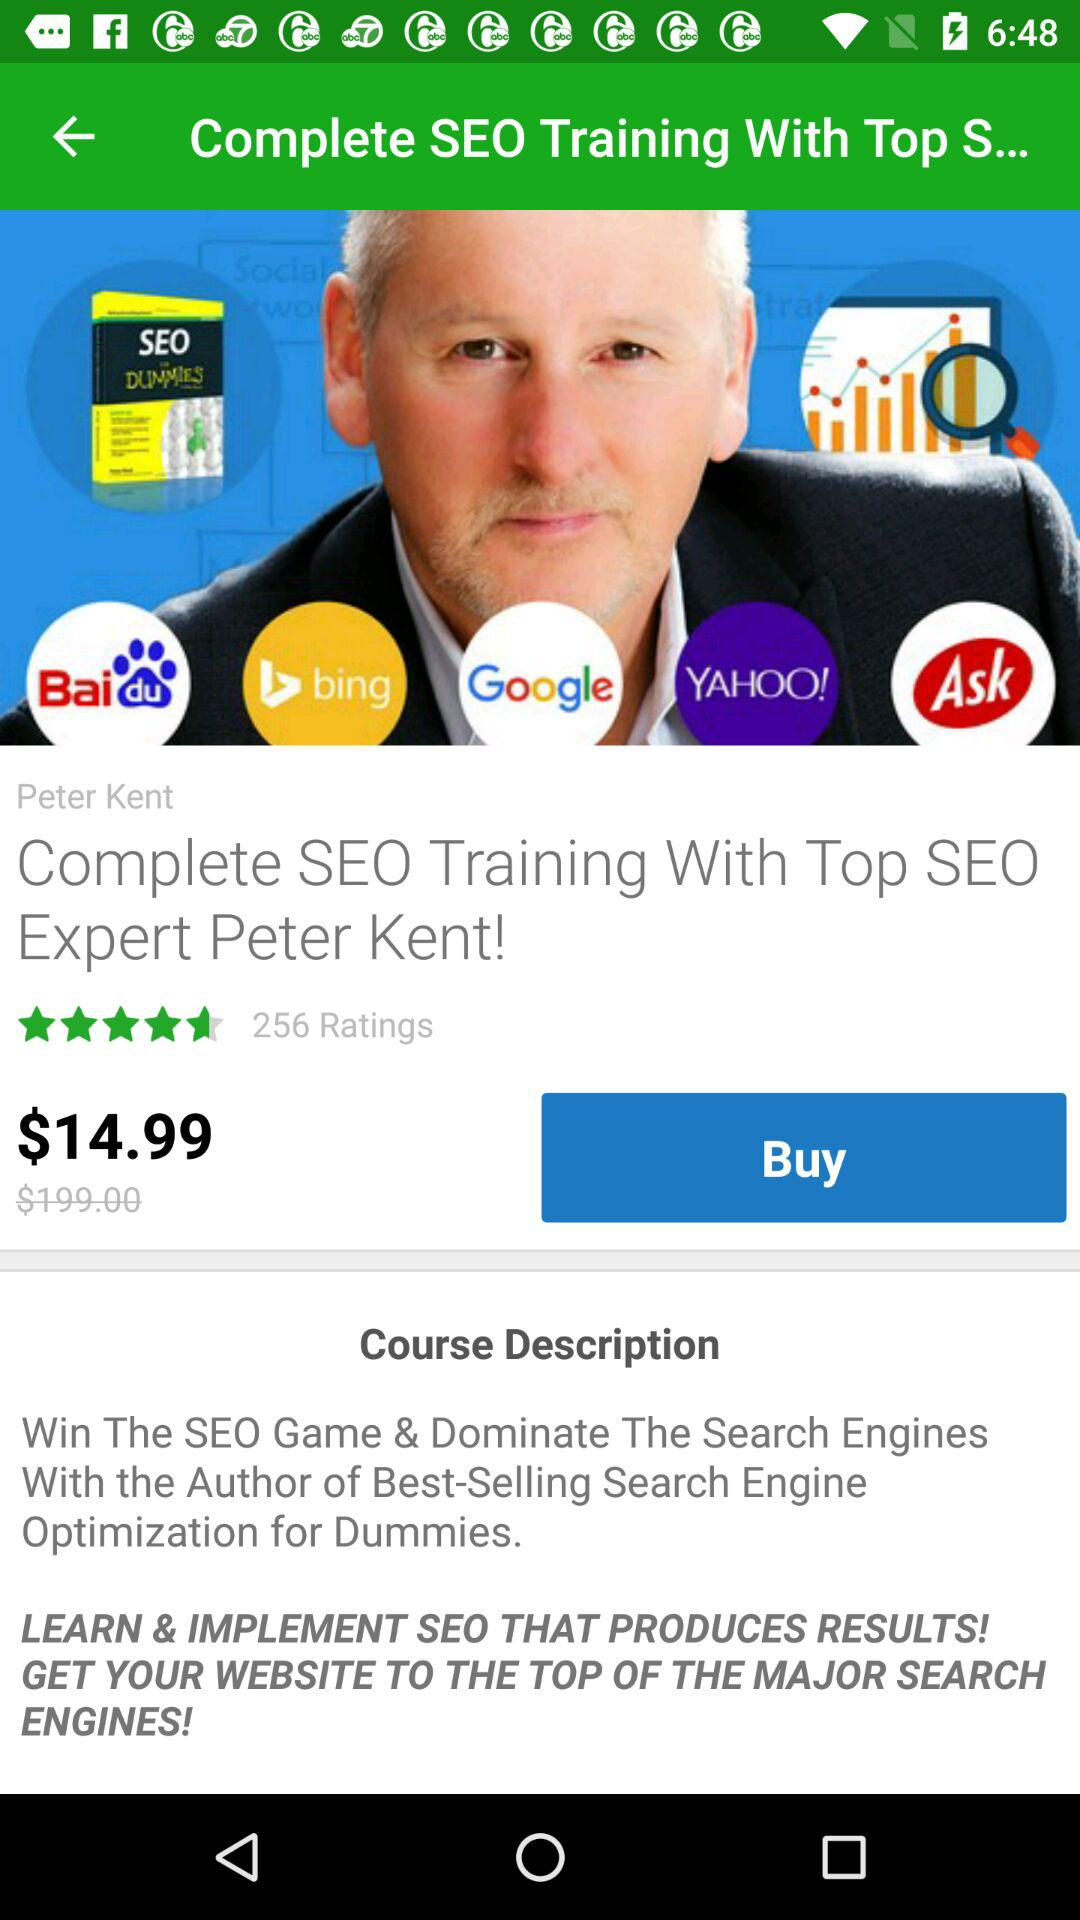What is the price of the book? The price of the book is $14.99. 